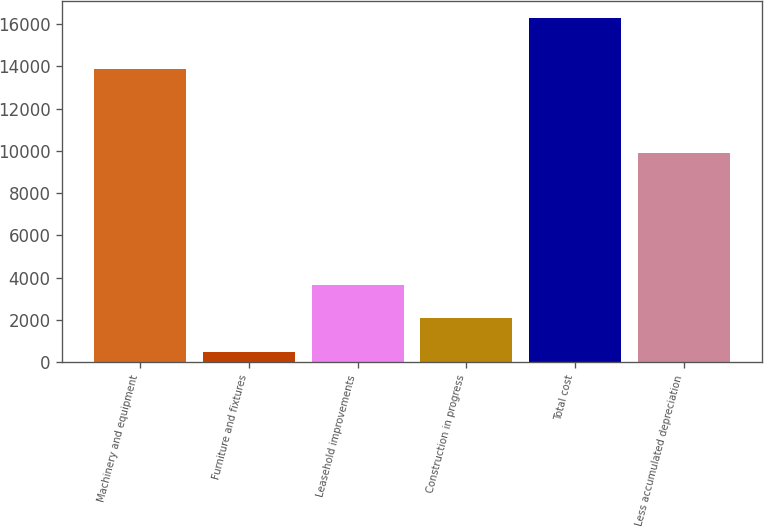Convert chart to OTSL. <chart><loc_0><loc_0><loc_500><loc_500><bar_chart><fcel>Machinery and equipment<fcel>Furniture and fixtures<fcel>Leasehold improvements<fcel>Construction in progress<fcel>Total cost<fcel>Less accumulated depreciation<nl><fcel>13860<fcel>498<fcel>3653<fcel>2075.5<fcel>16273<fcel>9895<nl></chart> 